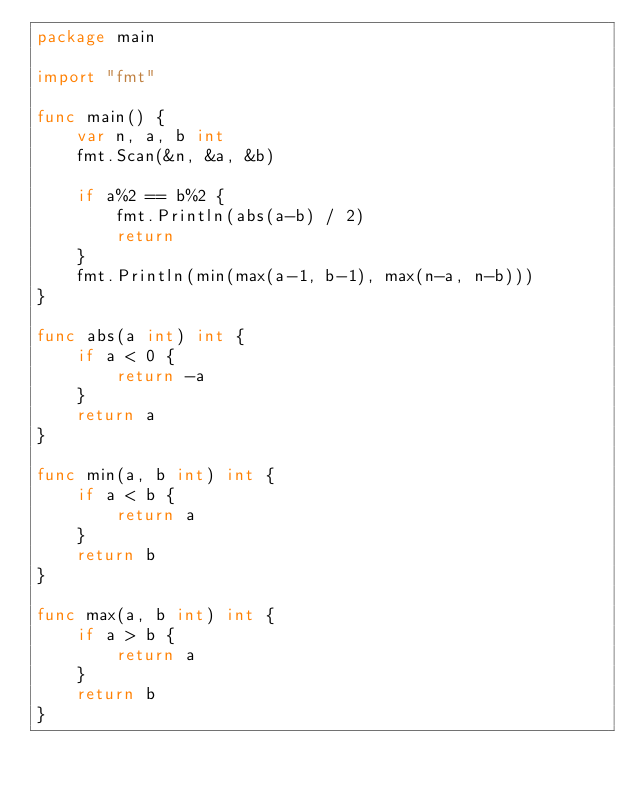Convert code to text. <code><loc_0><loc_0><loc_500><loc_500><_Go_>package main

import "fmt"

func main() {
	var n, a, b int
	fmt.Scan(&n, &a, &b)

	if a%2 == b%2 {
		fmt.Println(abs(a-b) / 2)
		return
	}
	fmt.Println(min(max(a-1, b-1), max(n-a, n-b)))
}

func abs(a int) int {
	if a < 0 {
		return -a
	}
	return a
}

func min(a, b int) int {
	if a < b {
		return a
	}
	return b
}

func max(a, b int) int {
	if a > b {
		return a
	}
	return b
}
</code> 